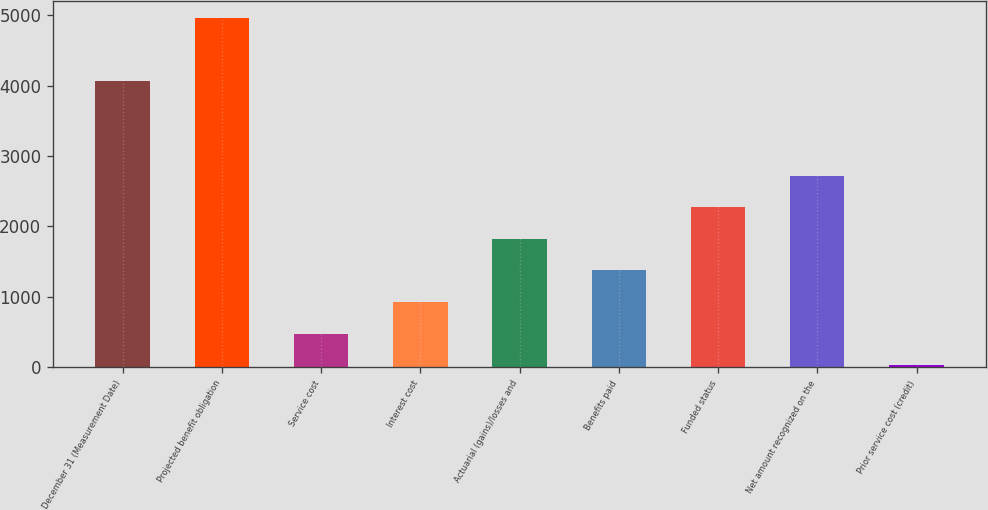Convert chart to OTSL. <chart><loc_0><loc_0><loc_500><loc_500><bar_chart><fcel>December 31 (Measurement Date)<fcel>Projected benefit obligation<fcel>Service cost<fcel>Interest cost<fcel>Actuarial (gains)/losses and<fcel>Benefits paid<fcel>Funded status<fcel>Net amount recognized on the<fcel>Prior service cost (credit)<nl><fcel>4063.9<fcel>4960.1<fcel>479.1<fcel>927.2<fcel>1823.4<fcel>1375.3<fcel>2271.5<fcel>2719.6<fcel>31<nl></chart> 